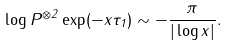<formula> <loc_0><loc_0><loc_500><loc_500>\log P ^ { \otimes 2 } \exp ( - x \tau _ { 1 } ) \sim - \frac { \pi } { | \log x | } .</formula> 